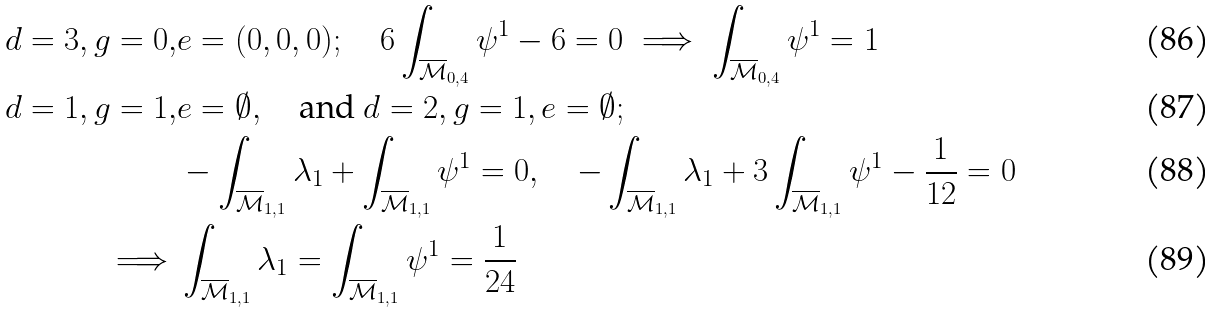<formula> <loc_0><loc_0><loc_500><loc_500>d = 3 , g = 0 , & e = ( 0 , 0 , 0 ) ; \quad 6 \int _ { \overline { \mathcal { M } } _ { 0 , 4 } } \psi ^ { 1 } - 6 = 0 \implies \int _ { \overline { \mathcal { M } } _ { 0 , 4 } } \psi ^ { 1 } = 1 \\ d = 1 , g = 1 , & e = \emptyset , \quad \text {and } d = 2 , g = 1 , e = \emptyset ; \\ & - \int _ { \overline { \mathcal { M } } _ { 1 , 1 } } \lambda _ { 1 } + \int _ { \overline { \mathcal { M } } _ { 1 , 1 } } \psi ^ { 1 } = 0 , \quad - \int _ { \overline { \mathcal { M } } _ { 1 , 1 } } \lambda _ { 1 } + 3 \int _ { \overline { \mathcal { M } } _ { 1 , 1 } } \psi ^ { 1 } - \frac { 1 } { 1 2 } = 0 \\ \implies & \int _ { \overline { \mathcal { M } } _ { 1 , 1 } } \lambda _ { 1 } = \int _ { \overline { \mathcal { M } } _ { 1 , 1 } } \psi ^ { 1 } = \frac { 1 } { 2 4 }</formula> 